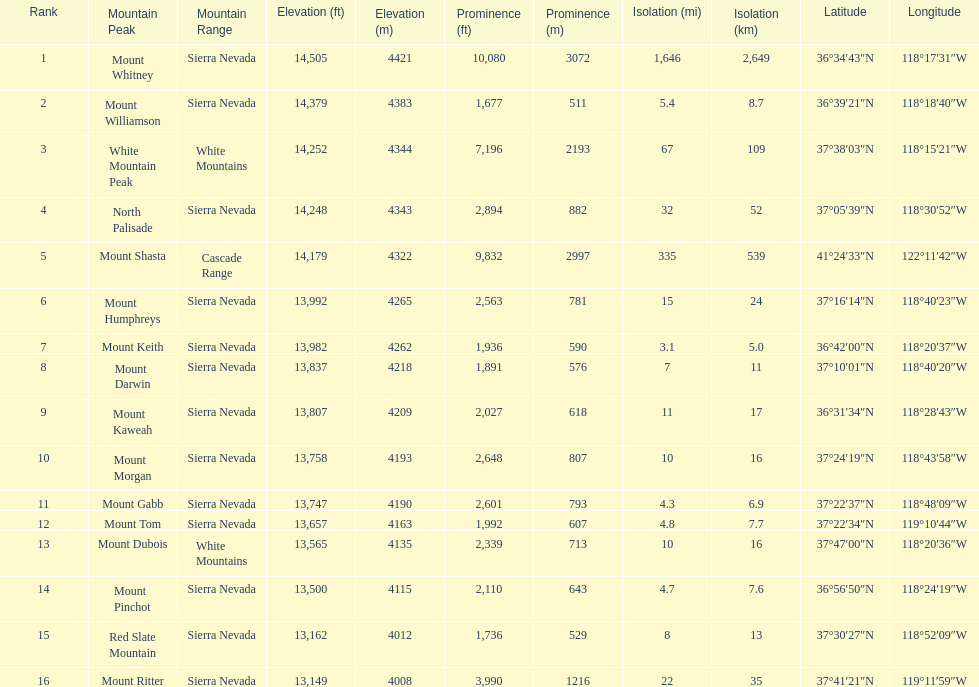Could you help me parse every detail presented in this table? {'header': ['Rank', 'Mountain Peak', 'Mountain Range', 'Elevation (ft)', 'Elevation (m)', 'Prominence (ft)', 'Prominence (m)', 'Isolation (mi)', 'Isolation (km)', 'Latitude', 'Longitude'], 'rows': [['1', 'Mount Whitney', 'Sierra Nevada', '14,505', '4421', '10,080', '3072', '1,646', '2,649', '36°34′43″N', '118°17′31″W'], ['2', 'Mount Williamson', 'Sierra Nevada', '14,379', '4383', '1,677', '511', '5.4', '8.7', '36°39′21″N', '118°18′40″W'], ['3', 'White Mountain Peak', 'White Mountains', '14,252', '4344', '7,196', '2193', '67', '109', '37°38′03″N', '118°15′21″W'], ['4', 'North Palisade', 'Sierra Nevada', '14,248', '4343', '2,894', '882', '32', '52', '37°05′39″N', '118°30′52″W'], ['5', 'Mount Shasta', 'Cascade Range', '14,179', '4322', '9,832', '2997', '335', '539', '41°24′33″N', '122°11′42″W'], ['6', 'Mount Humphreys', 'Sierra Nevada', '13,992', '4265', '2,563', '781', '15', '24', '37°16′14″N', '118°40′23″W'], ['7', 'Mount Keith', 'Sierra Nevada', '13,982', '4262', '1,936', '590', '3.1', '5.0', '36°42′00″N', '118°20′37″W'], ['8', 'Mount Darwin', 'Sierra Nevada', '13,837', '4218', '1,891', '576', '7', '11', '37°10′01″N', '118°40′20″W'], ['9', 'Mount Kaweah', 'Sierra Nevada', '13,807', '4209', '2,027', '618', '11', '17', '36°31′34″N', '118°28′43″W'], ['10', 'Mount Morgan', 'Sierra Nevada', '13,758', '4193', '2,648', '807', '10', '16', '37°24′19″N', '118°43′58″W'], ['11', 'Mount Gabb', 'Sierra Nevada', '13,747', '4190', '2,601', '793', '4.3', '6.9', '37°22′37″N', '118°48′09″W'], ['12', 'Mount Tom', 'Sierra Nevada', '13,657', '4163', '1,992', '607', '4.8', '7.7', '37°22′34″N', '119°10′44″W'], ['13', 'Mount Dubois', 'White Mountains', '13,565', '4135', '2,339', '713', '10', '16', '37°47′00″N', '118°20′36″W'], ['14', 'Mount Pinchot', 'Sierra Nevada', '13,500', '4115', '2,110', '643', '4.7', '7.6', '36°56′50″N', '118°24′19″W'], ['15', 'Red Slate Mountain', 'Sierra Nevada', '13,162', '4012', '1,736', '529', '8', '13', '37°30′27″N', '118°52′09″W'], ['16', 'Mount Ritter', 'Sierra Nevada', '13,149', '4008', '3,990', '1216', '22', '35', '37°41′21″N', '119°11′59″W']]} Which mountain peak has a prominence more than 10,000 ft? Mount Whitney. 